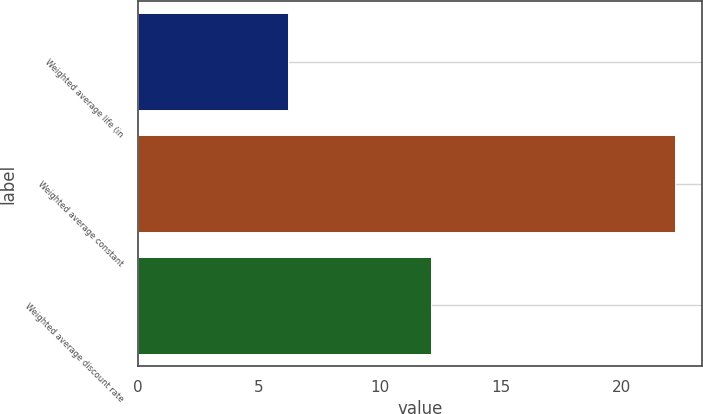Convert chart to OTSL. <chart><loc_0><loc_0><loc_500><loc_500><bar_chart><fcel>Weighted average life (in<fcel>Weighted average constant<fcel>Weighted average discount rate<nl><fcel>6.2<fcel>22.2<fcel>12.1<nl></chart> 